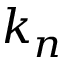<formula> <loc_0><loc_0><loc_500><loc_500>k _ { n }</formula> 